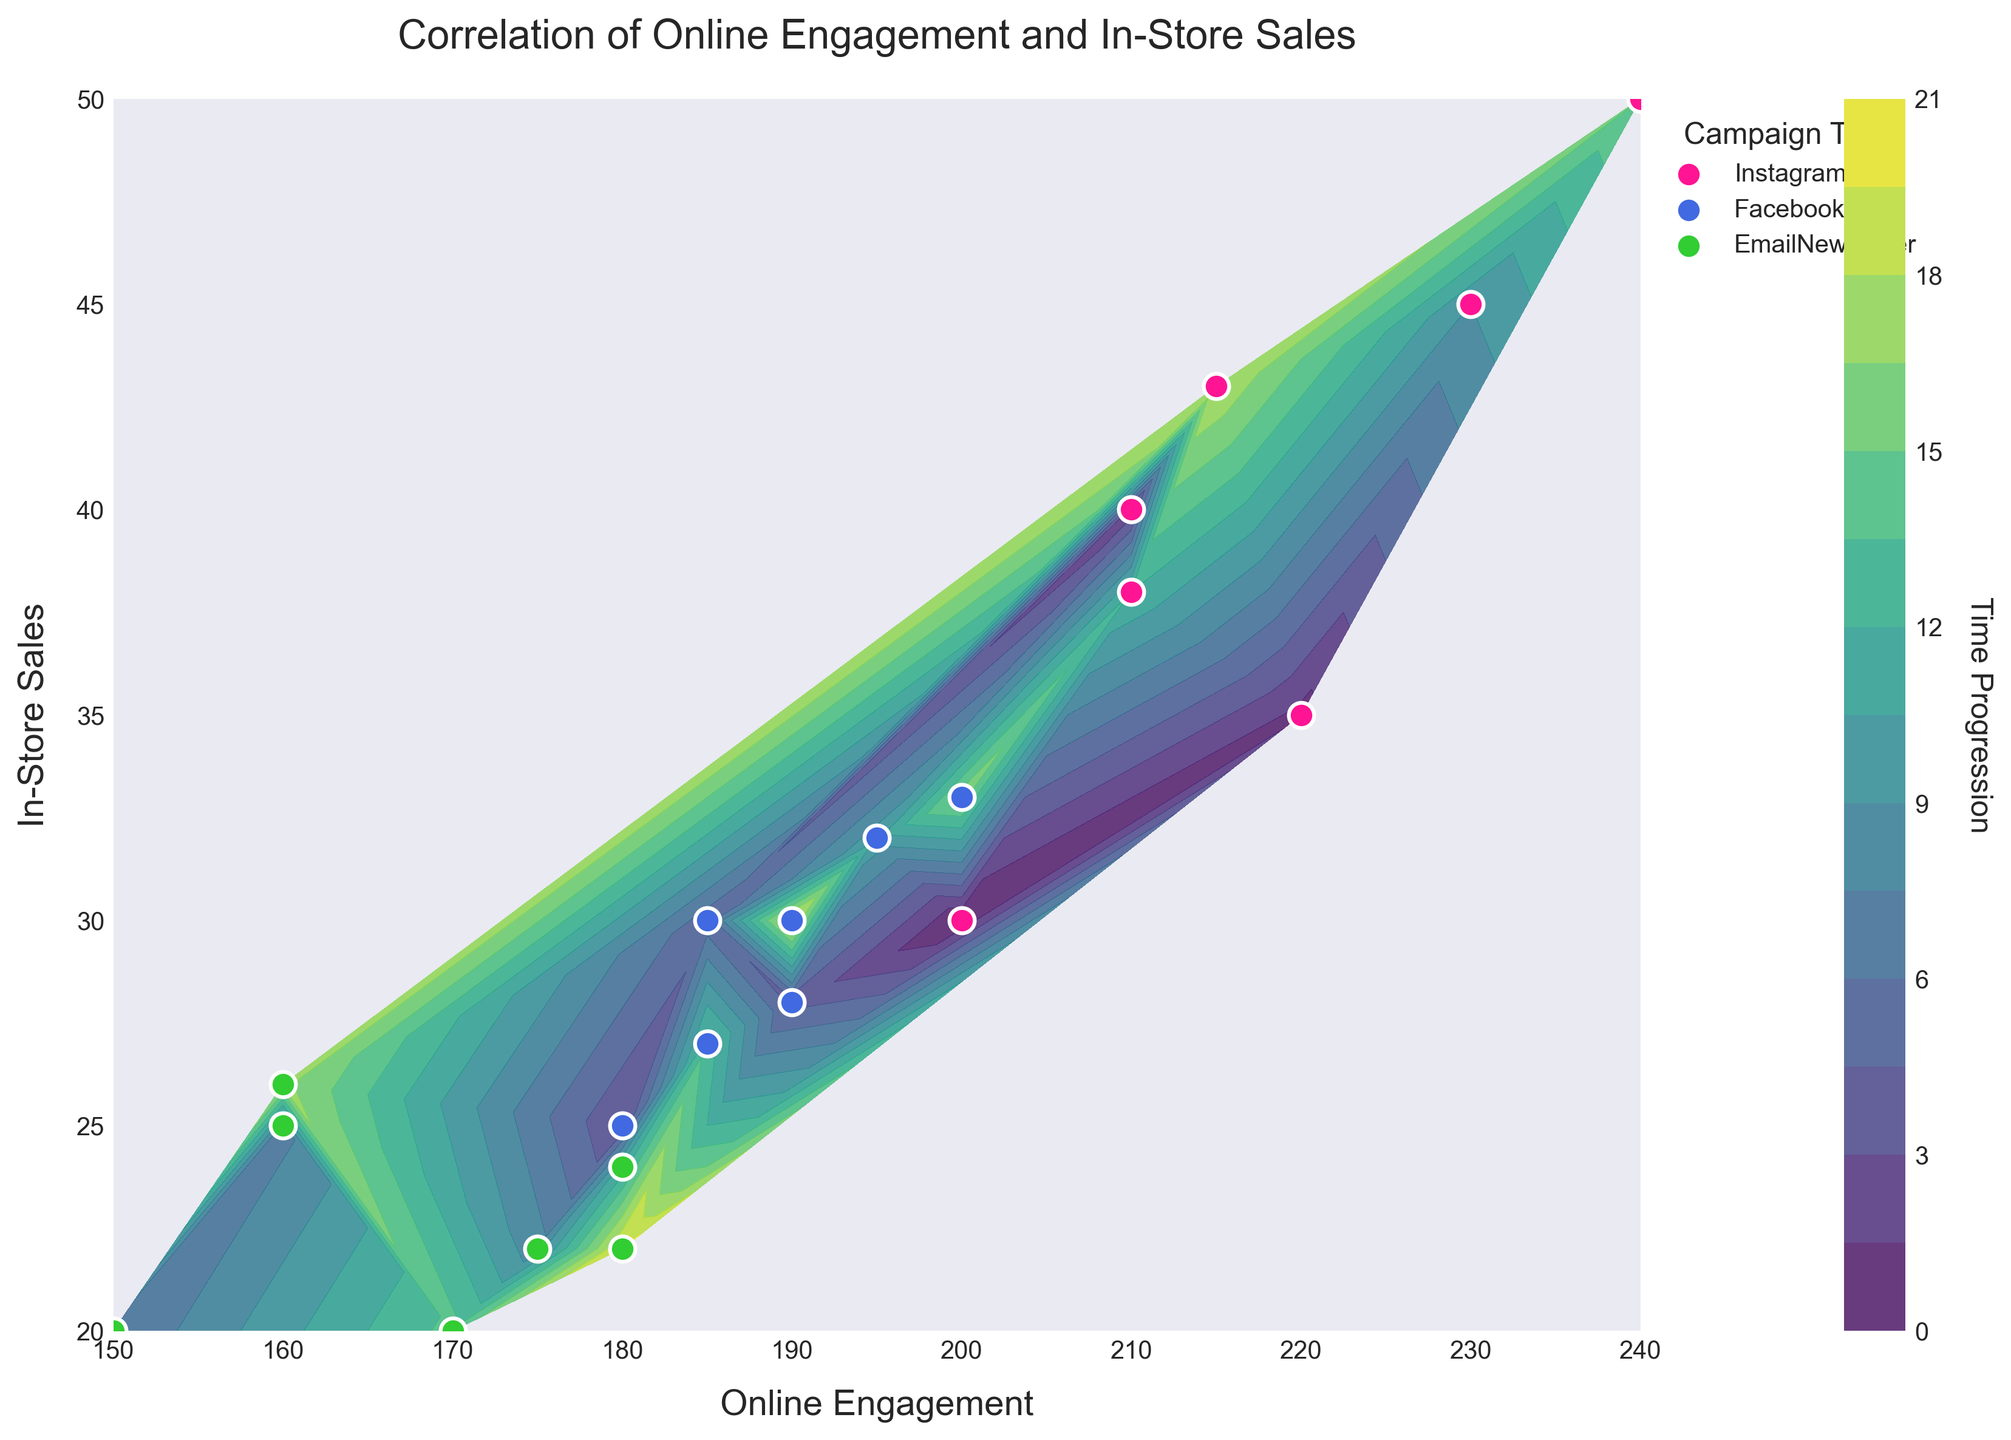How many campaign types are displayed in the legend? The legend shows three different colors/markers, each representing a unique campaign type: InstagramAds, FacebookAds, and EmailNewsletter.
Answer: 3 What is the title of the plot? The title is written at the top of the plot and reads: "Correlation of Online Engagement and In-Store Sales."
Answer: Correlation of Online Engagement and In-Store Sales Which color represents the InstagramAds campaign in the scatter plot? By looking at the legend on the right side, we can see that the InstagramAds campaign is represented by the color pink.
Answer: Pink Which campaign type has the highest online engagement and what is that value? The color corresponding to InstagramAds (pink) marks the highest point on the x-axis, which is the value of 240 for Online Engagement.
Answer: InstagramAds, 240 Where is data from the EmailNewsletter campaign mostly clustered in terms of online engagement and in-store sales? The green dots representing the EmailNewsletter campaign are mainly situated in a lower range on both axes: Online Engagement between 150-180 and In-Store Sales between 20-26.
Answer: Online Engagement: 150-180, In-Store Sales: 20-26 Is there a clear trend or correlation between Online Engagement and In-Store Sales? The contour lines and the scatter points, especially for distinct campaign types, show a positive correlation. As online engagement increases, in-store sales also tend to increase.
Answer: Positive correlation Which campaign type generally has the highest in-store sales? Referring to the color-coded legend and scatter points, InstagramAds (pink dots) tend to have higher values on the y-axis (In-Store Sales), with several points exceeding 40.
Answer: InstagramAds How does the color-graded contour plot provide additional information about the dataset's time progression? The color grading on the contour plot indicates the z-values, representing time progression. Darker shades suggest earlier dates and lighter shades indicate later dates. This gives insights into how data points evolve over time.
Answer: Shade progression indicates time How do you differentiate between different campaign types in the scatter plot? The different campaign types are differentiated through distinct colors and marker styles: pink for InstagramAds, blue for FacebookAds, and green for EmailNewsletter, as indicated in the legend.
Answer: Different colors and markers What does the color bar represent in the plot? The color bar to the right of the plot shows the gradient used in the contour plot. It represents time progression, with specific colors corresponding to different points in time.
Answer: Time progression 